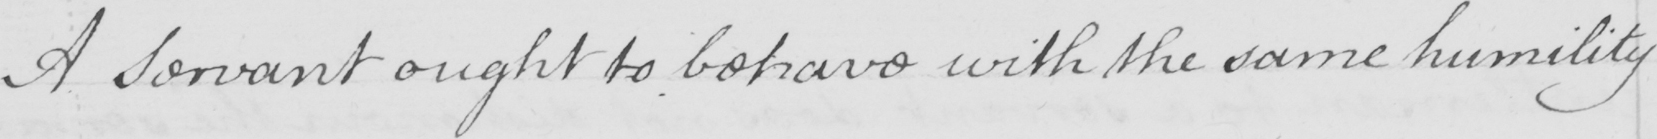What does this handwritten line say? A servant ought to behave with the same humility 